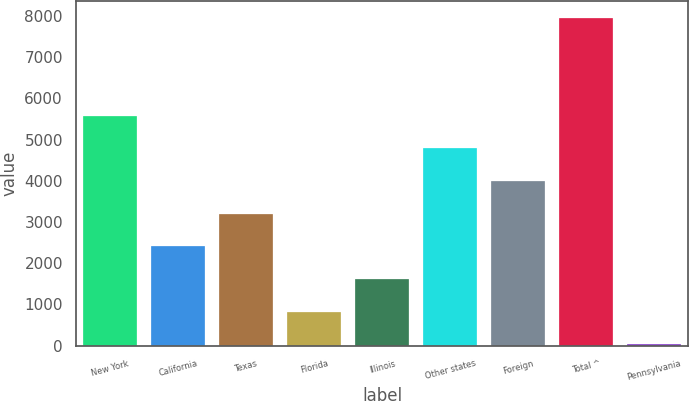Convert chart. <chart><loc_0><loc_0><loc_500><loc_500><bar_chart><fcel>New York<fcel>California<fcel>Texas<fcel>Florida<fcel>Illinois<fcel>Other states<fcel>Foreign<fcel>Total ^<fcel>Pennsylvania<nl><fcel>5583.5<fcel>2409.5<fcel>3203<fcel>822.5<fcel>1616<fcel>4790<fcel>3996.5<fcel>7964<fcel>29<nl></chart> 